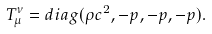<formula> <loc_0><loc_0><loc_500><loc_500>T _ { \mu } ^ { \nu } = d i a g ( \rho c ^ { 2 } , - p , - p , - p ) .</formula> 